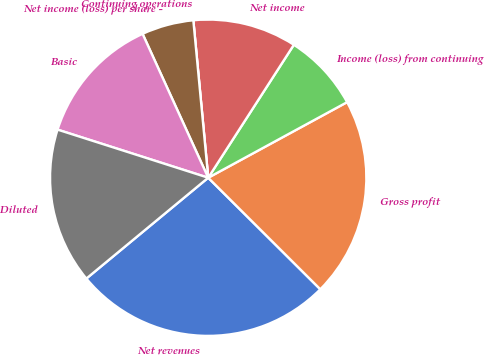<chart> <loc_0><loc_0><loc_500><loc_500><pie_chart><fcel>Net revenues<fcel>Gross profit<fcel>Income (loss) from continuing<fcel>Net income<fcel>Continuing operations<fcel>Net income (loss) per share -<fcel>Basic<fcel>Diluted<nl><fcel>26.54%<fcel>20.39%<fcel>7.96%<fcel>10.61%<fcel>0.0%<fcel>5.31%<fcel>13.27%<fcel>15.92%<nl></chart> 